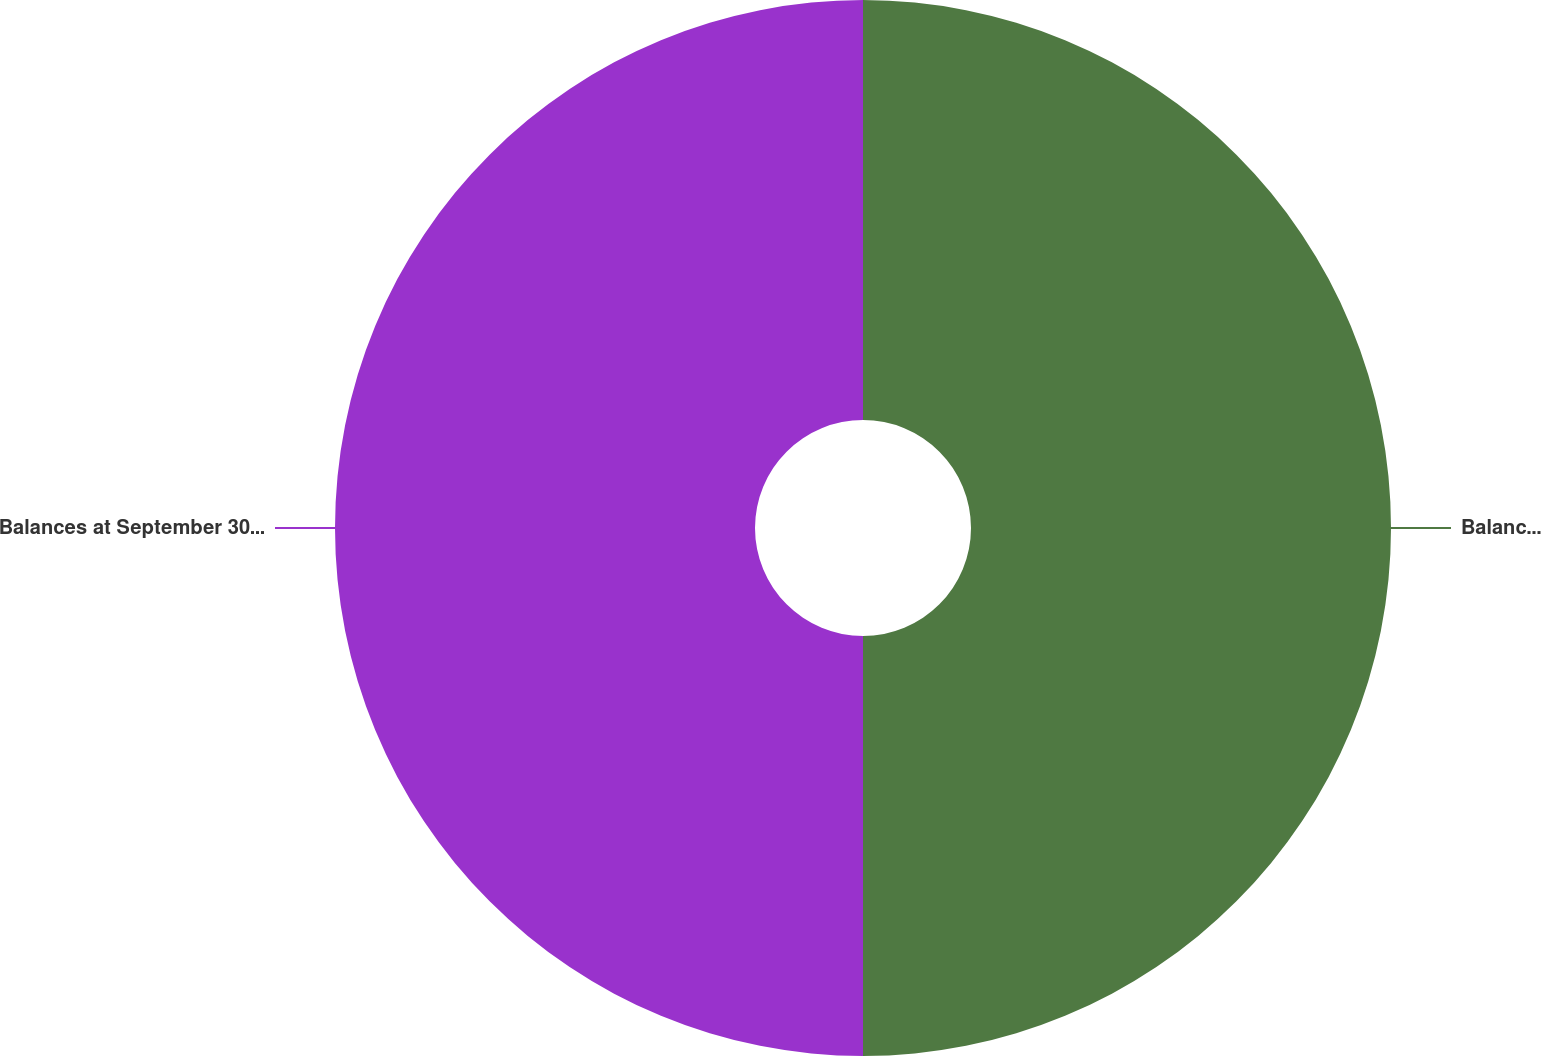Convert chart to OTSL. <chart><loc_0><loc_0><loc_500><loc_500><pie_chart><fcel>Balances at September 24 2004<fcel>Balances at September 30 2005<nl><fcel>50.0%<fcel>50.0%<nl></chart> 